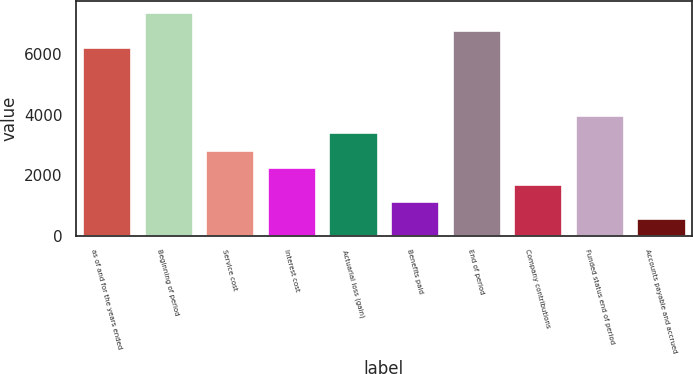Convert chart. <chart><loc_0><loc_0><loc_500><loc_500><bar_chart><fcel>as of and for the years ended<fcel>Beginning of period<fcel>Service cost<fcel>Interest cost<fcel>Actuarial loss (gain)<fcel>Benefits paid<fcel>End of period<fcel>Company contributions<fcel>Funded status end of period<fcel>Accounts payable and accrued<nl><fcel>6247.5<fcel>7380.5<fcel>2848.5<fcel>2282<fcel>3415<fcel>1149<fcel>6814<fcel>1715.5<fcel>3981.5<fcel>582.5<nl></chart> 